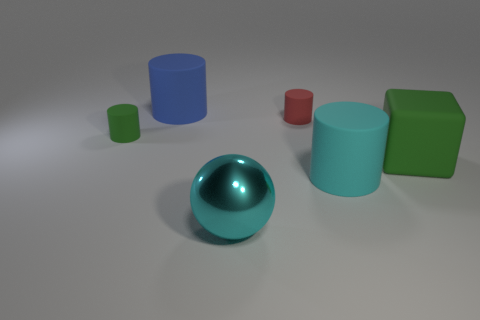Can you describe the lighting in the scene and its effect on the objects? The lighting appears to be soft and diffused, coming from overhead, which creates gentle shadows beneath the objects. This soft lighting minimizes harsh reflections and helps maintain the visibility of the objects' colors and textures. 